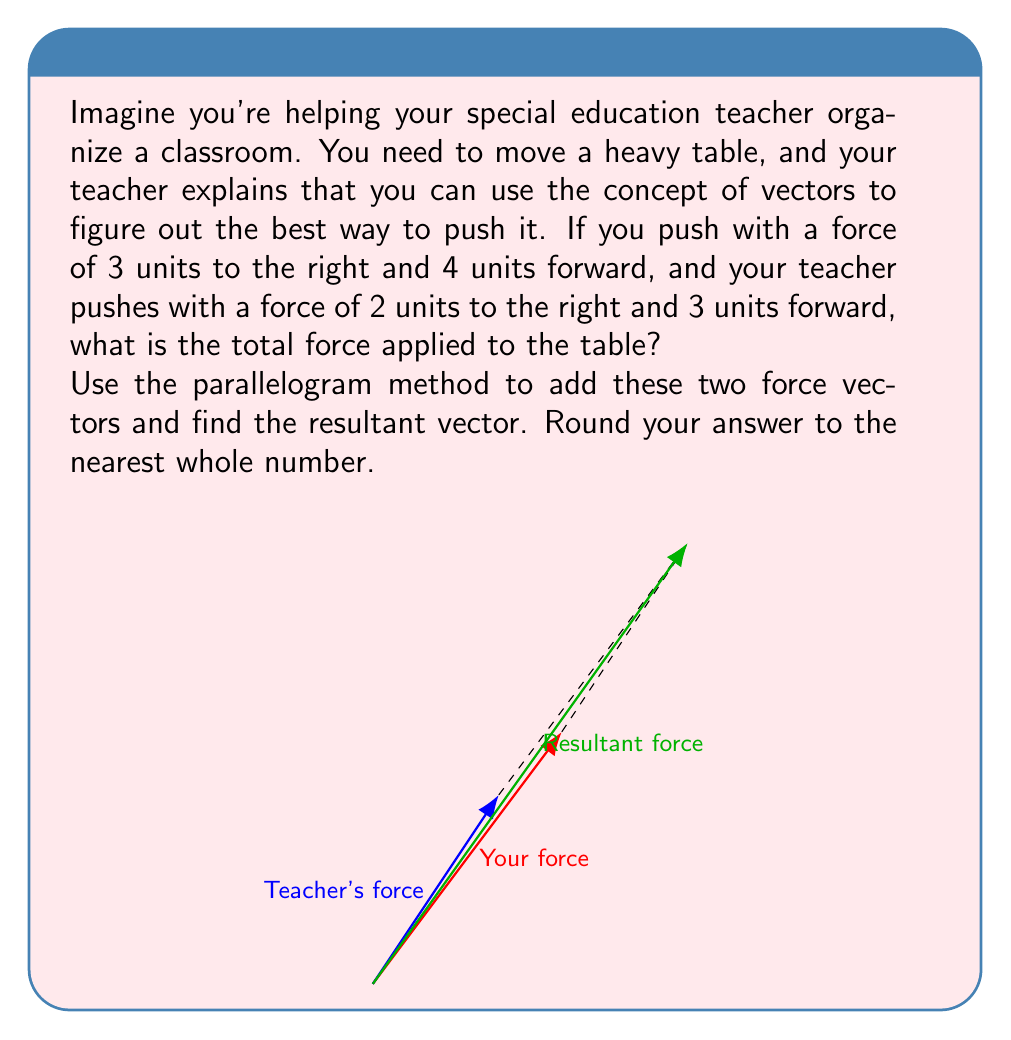Solve this math problem. Let's solve this step-by-step:

1) First, let's identify our vectors:
   Your force: $\vec{a} = (3, 4)$
   Teacher's force: $\vec{b} = (2, 3)$

2) To add these vectors using the parallelogram method, we need to:
   a) Place the vectors tail-to-tail
   b) Complete the parallelogram
   c) Draw the diagonal from the common starting point

3) The diagonal of the parallelogram represents the resultant vector. We can find its components by adding the components of the original vectors:

   $\vec{r} = \vec{a} + \vec{b} = (3+2, 4+3) = (5, 7)$

4) Now we have the components of the resultant vector, but we need to find its magnitude (length). We can do this using the Pythagorean theorem:

   $|\vec{r}| = \sqrt{x^2 + y^2} = \sqrt{5^2 + 7^2} = \sqrt{25 + 49} = \sqrt{74}$

5) Calculate this value:
   $\sqrt{74} \approx 8.602$

6) Rounding to the nearest whole number:
   $8.602 \approx 9$

Therefore, the total force applied to the table is approximately 9 units.
Answer: 9 units 